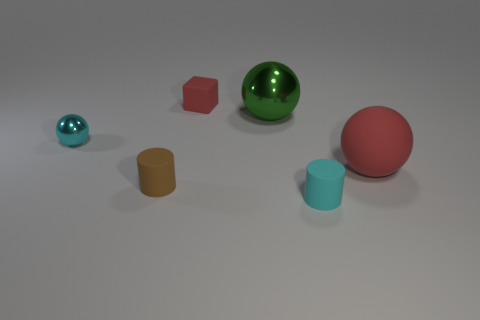Subtract all big balls. How many balls are left? 1 Add 1 small metallic things. How many objects exist? 7 Subtract all cubes. How many objects are left? 5 Subtract 0 red cylinders. How many objects are left? 6 Subtract all green shiny spheres. Subtract all small brown rubber cylinders. How many objects are left? 4 Add 4 blocks. How many blocks are left? 5 Add 6 tiny shiny spheres. How many tiny shiny spheres exist? 7 